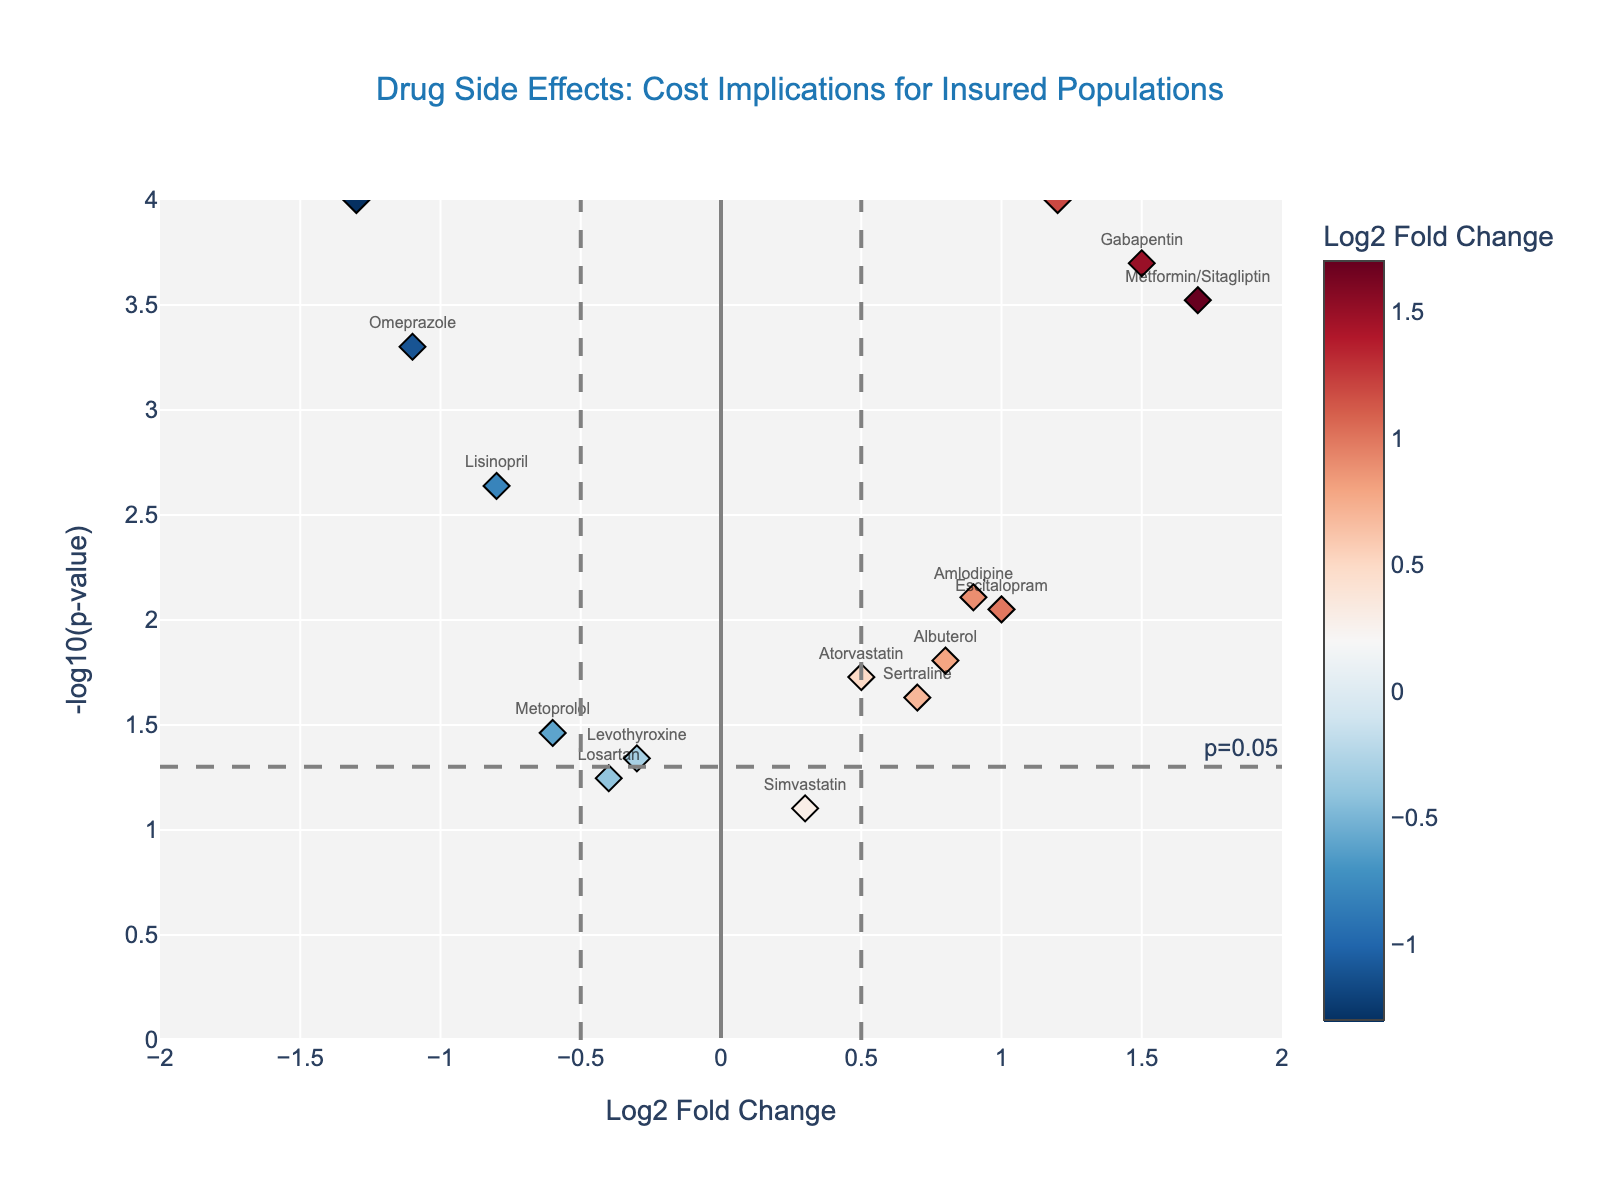What's the title of the figure? Look at the top of the figure where the title is located.
Answer: Drug Side Effects: Cost Implications for Insured Populations What do the x-axis and y-axis represent? The x-axis title is visible at the bottom and the y-axis title at the left side of the plot.
Answer: The x-axis represents Log2 Fold Change, and the y-axis represents -log10(p-value) How many drugs are displayed in the plot? Each marker represents a drug, and each marker is labeled with the name of the drug. Count the labeled names.
Answer: 15 Which drug has the highest -log10(p-value)? Find the marker that appears at the top of the plot, indicating the highest y-axis value.
Answer: Metformin Identify the drugs with a Log2 Fold Change greater than 1.0. Look at the x-axis values and select markers that are to the right of x = 1.0.
Answer: Metformin, Gabapentin, Metformin/Sitagliptin Which drug has the most statistically significant negative Log2 Fold Change? Negative Log2 Fold Change markers are to the left of the origin. The most statistically significant has the highest -log10(p-value).
Answer: Hydrocodone Based on the plot, which drugs might have a higher cost implication due to higher prevalence? Higher Log2 Fold Changes (right side of the plot) indicate higher prevalence, suggesting higher cost implications.
Answer: Metformin, Gabapentin, Metformin/Sitagliptin, Amlodipine, Escitalopram Compare the Log2 Fold Change of Metformin and Omeprazole. Which one is higher? Locate both markers and compare their x-axis (horizontal) positions.
Answer: Metformin Between Lisinopril and Sertraline, which one appears to be less significant in terms of p-value? Find both drugs and compare their -log10(p) values, with higher values indicating more significance.
Answer: Sertraline Are there any drugs that are not statistically significant (with p-value > 0.05)? Check markers below the threshold line y = -log10(0.05), any markers below this line have p-value > 0.05.
Answer: Simvastatin, Losartan 